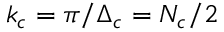Convert formula to latex. <formula><loc_0><loc_0><loc_500><loc_500>k _ { c } = \pi / \Delta _ { c } = N _ { c } / 2</formula> 